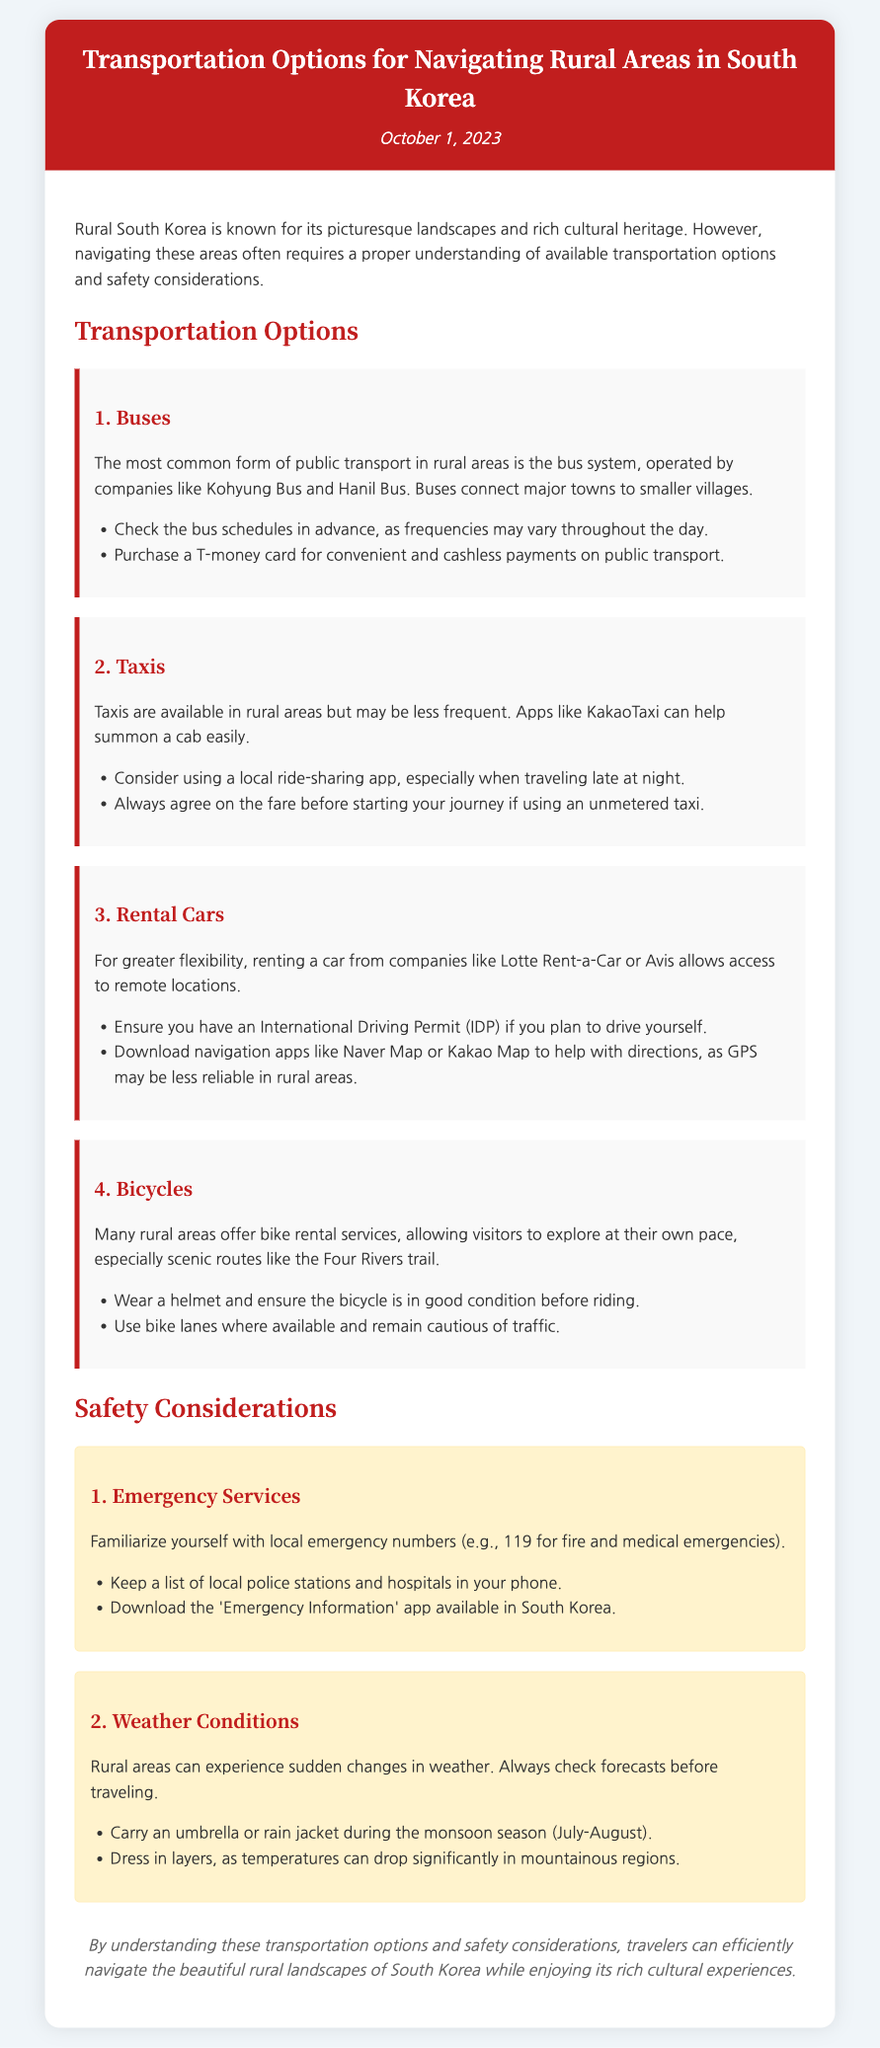what is the title of the document? The title of the document is included in the header section and describes the focus on transportation options in rural South Korea.
Answer: Transportation Options for Navigating Rural Areas in South Korea when was the memo published? The date of publication is presented below the title in the header section.
Answer: October 1, 2023 who operates the bus system in rural areas? The document mentions specific bus companies that operate in rural areas, indicating who's responsible for it.
Answer: Kohyung Bus and Hanil Bus what is required for renting a car? The document provides information about necessary documents for renting a car, specifically focusing on any permits needed.
Answer: International Driving Permit (IDP) name one safety consideration related to weather. The memo highlights key safety considerations for travelers, including aspects related to changing weather conditions.
Answer: Check forecasts before traveling how can one summon a taxi easily in rural areas? The document suggests a specific tool available for travelers to request taxis, emphasizing convenience in less frequented areas.
Answer: KakaoTaxi what type of map is recommended for navigation? The text provides guidance on navigation tools, particularly emphasizing a useful app for directions in rural settings.
Answer: Naver Map or Kakao Map what is a tip for riding bicycles in rural areas? The document provides safety tips related to bicycle usage, ensuring travelers are informed on best practices.
Answer: Wear a helmet how should one prepare for sudden changes in weather? The document outlines practical advice on how to dress and prepare for unexpected weather conditions that may arise.
Answer: Dress in layers 